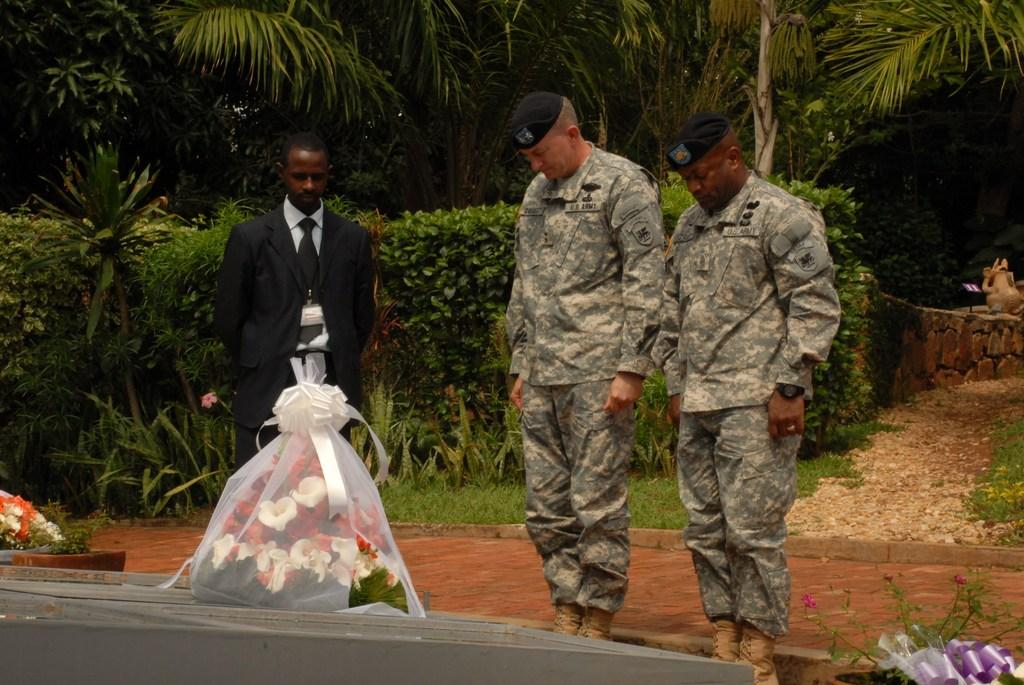How many people are present in the image? There are three people in the image. Where are the people located in the image? The people are standing at the bottom left side of the image. What type of flora can be seen in the image? There are flowers visible in the image. What is the background of the image composed of? There are many plants and trees at the back side of the image. What type of cattle can be seen grazing on the street in the image? There is no cattle or street present in the image; it features three people standing near flowers and a background of plants and trees. 